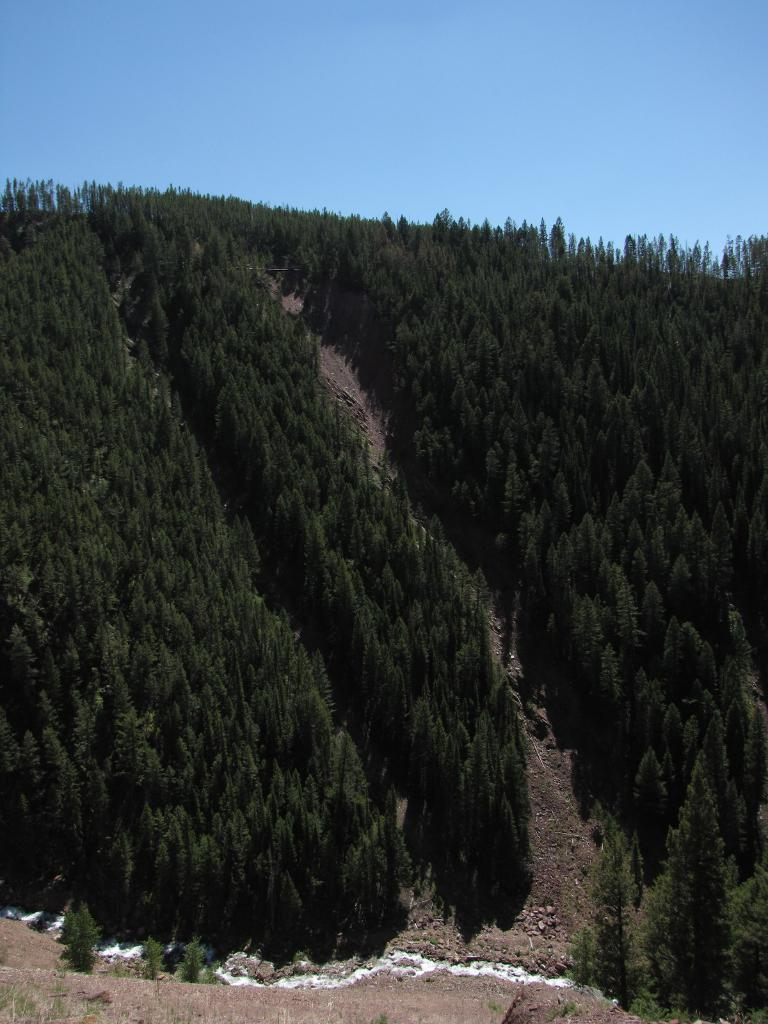What type of vegetation can be seen on the mountain in the image? There are trees on the mountain in the image. What can be seen at the bottom of the image? There is water flowing at the bottom of the image. What type of terrain is visible in the image? There are small stones visible in the image. What is visible at the top of the image? The sky is visible at the top of the image. How does the baby feel about the airplane in the image? There is no baby or airplane present in the image, so it is not possible to determine how a baby might feel about an airplane. 